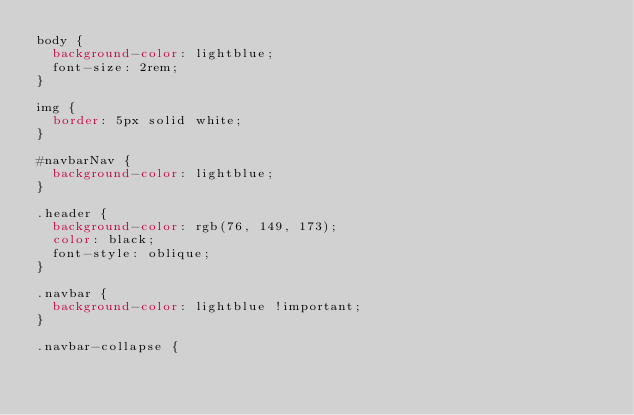Convert code to text. <code><loc_0><loc_0><loc_500><loc_500><_CSS_>body {
  background-color: lightblue;
  font-size: 2rem;
}

img {
  border: 5px solid white;
}

#navbarNav {
  background-color: lightblue;
}

.header {
  background-color: rgb(76, 149, 173);
  color: black;
  font-style: oblique;
}

.navbar {
  background-color: lightblue !important;
}

.navbar-collapse {</code> 